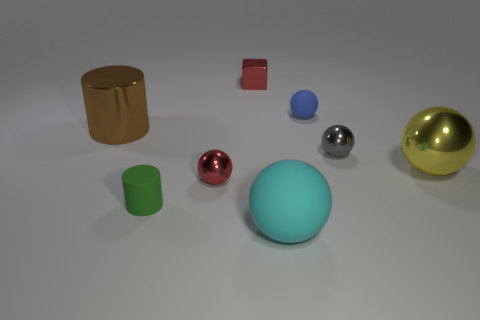How many other objects are there of the same shape as the big cyan object?
Your response must be concise. 4. How big is the object in front of the matte thing that is to the left of the red thing behind the blue object?
Provide a short and direct response. Large. Is the number of blue objects that are behind the metallic cylinder less than the number of large things on the left side of the blue thing?
Offer a terse response. Yes. How many tiny gray balls are made of the same material as the tiny red ball?
Give a very brief answer. 1. There is a rubber sphere on the left side of the small sphere behind the gray metal ball; is there a blue rubber ball that is in front of it?
Offer a very short reply. No. There is a small green object that is made of the same material as the blue thing; what is its shape?
Provide a short and direct response. Cylinder. Are there more small red blocks than small purple spheres?
Keep it short and to the point. Yes. Do the brown object and the small rubber thing that is on the left side of the big cyan matte ball have the same shape?
Ensure brevity in your answer.  Yes. What material is the blue object?
Your answer should be compact. Rubber. There is a ball that is on the left side of the ball in front of the green cylinder that is in front of the small gray thing; what is its color?
Offer a very short reply. Red. 